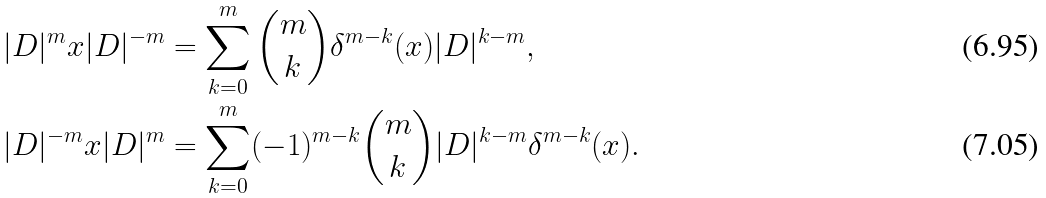Convert formula to latex. <formula><loc_0><loc_0><loc_500><loc_500>| D | ^ { m } x | D | ^ { - m } & = \sum _ { k = 0 } ^ { m } \binom { m } { k } \delta ^ { m - k } ( x ) | D | ^ { k - m } , \\ | D | ^ { - m } x | D | ^ { m } & = \sum _ { k = 0 } ^ { m } ( - 1 ) ^ { m - k } \binom { m } { k } | D | ^ { k - m } \delta ^ { m - k } ( x ) .</formula> 